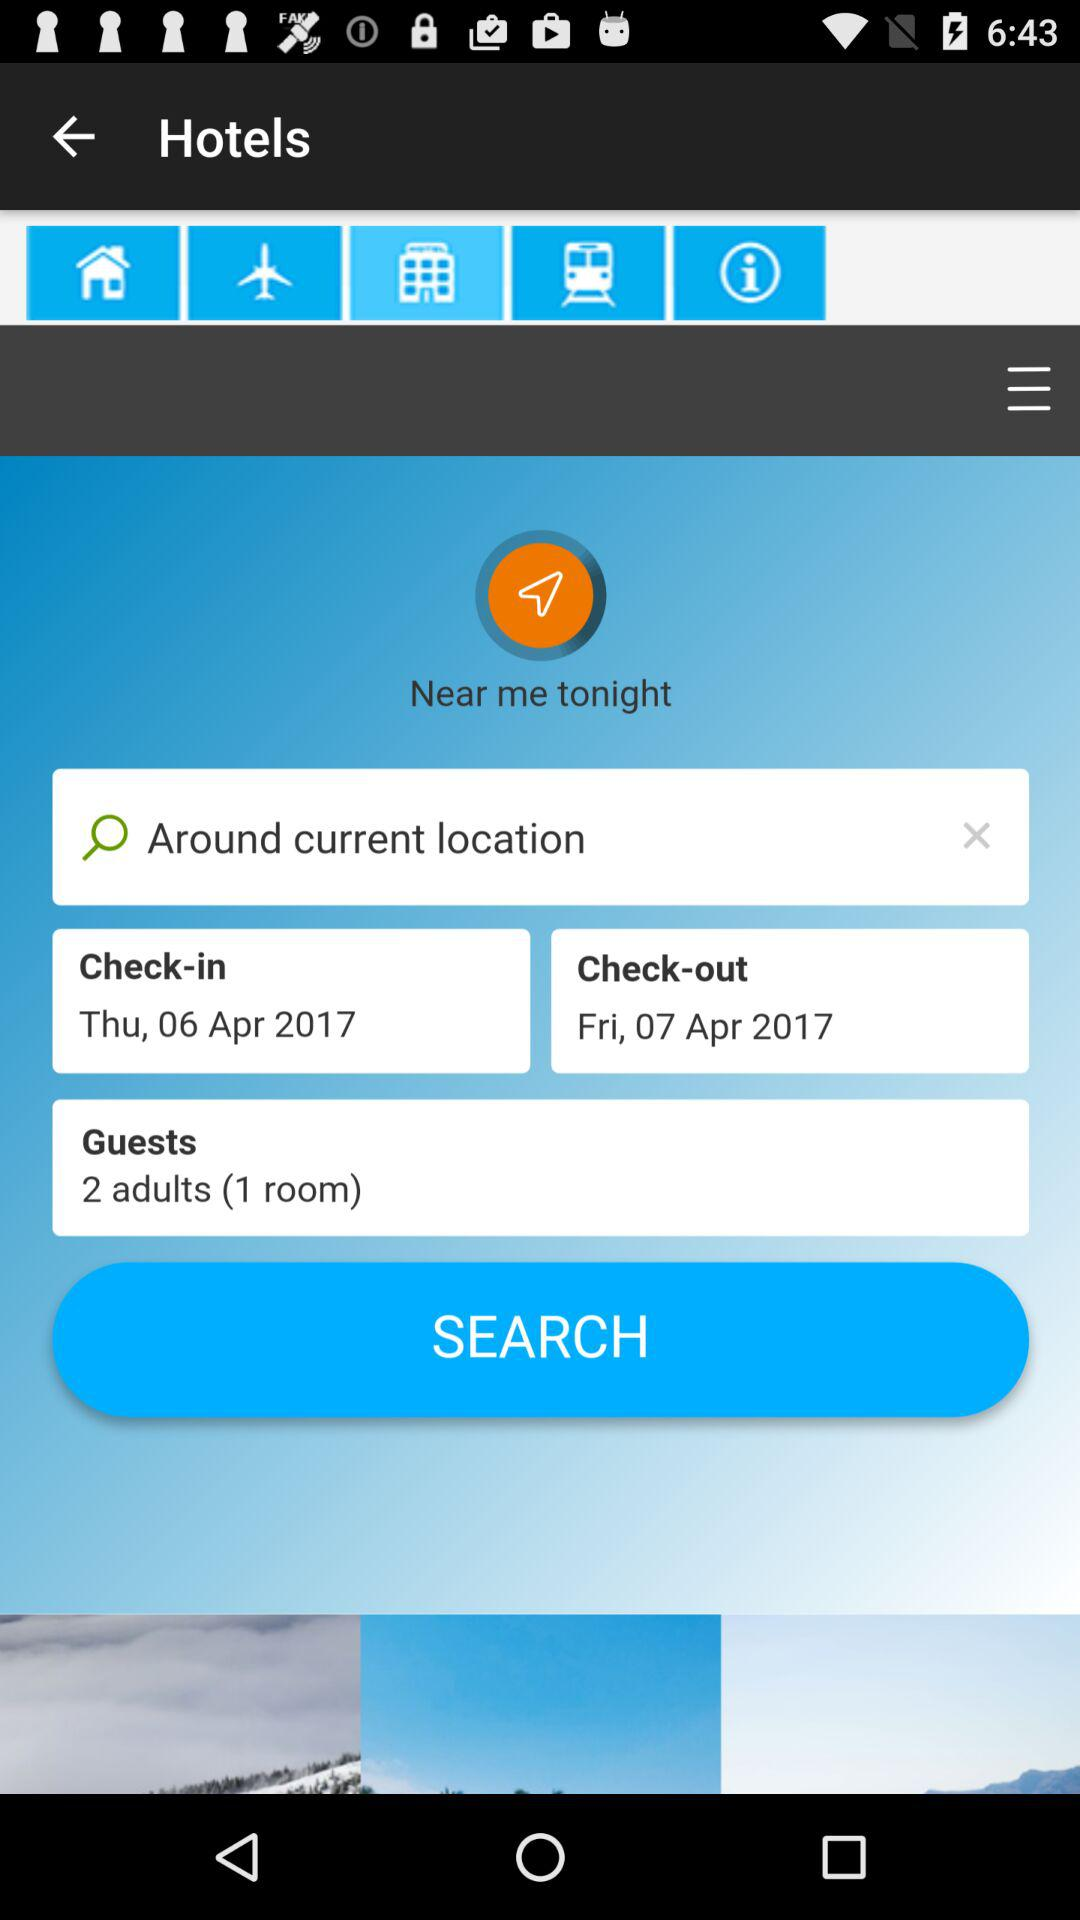What date is selected for check-in? The selected date is Thursday, April 6, 2017. 